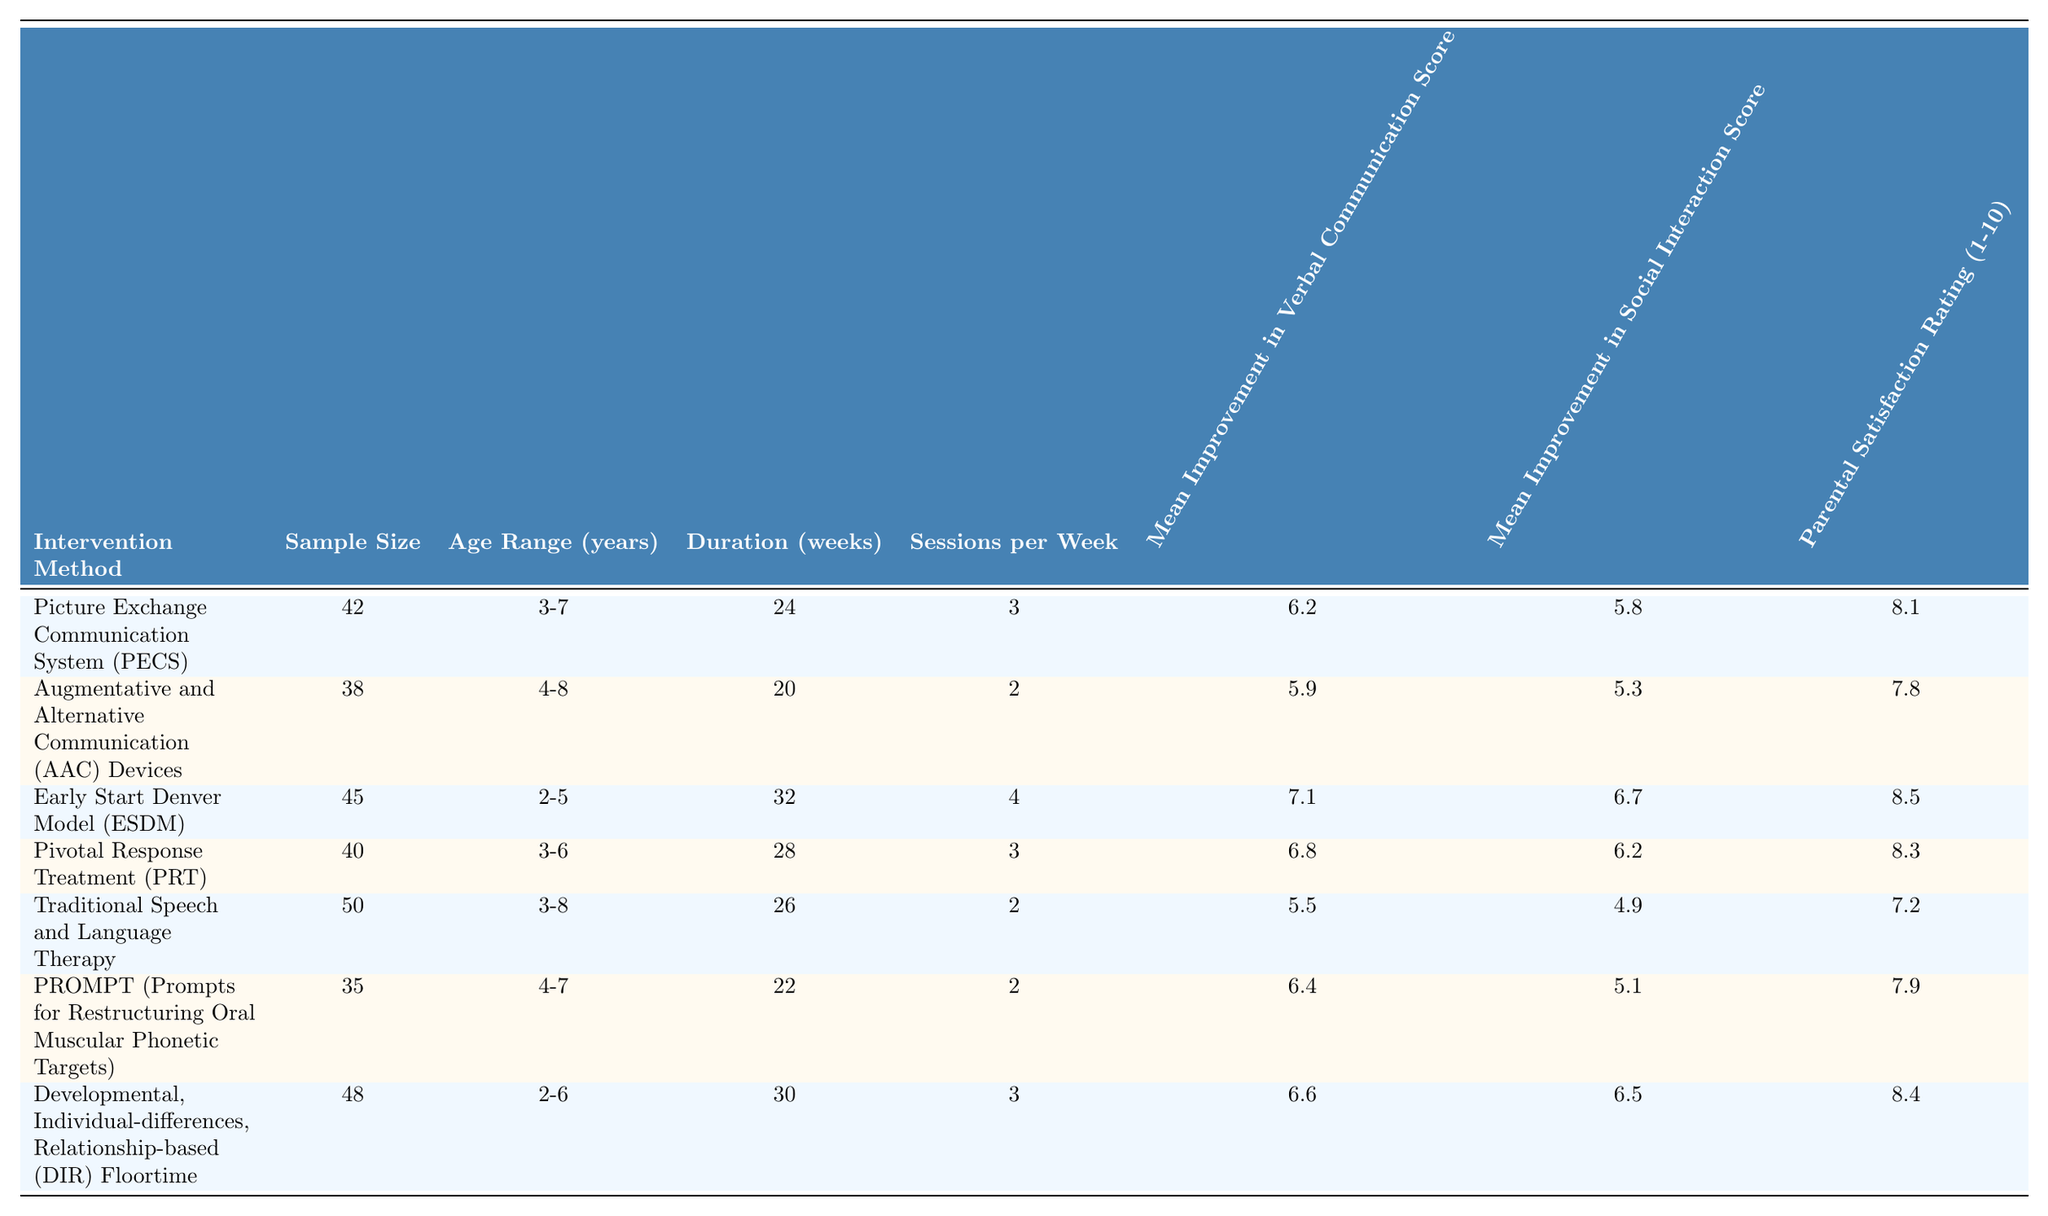What is the mean improvement in verbal communication score for the Early Start Denver Model (ESDM)? The table shows that the mean improvement in verbal communication score for ESDM is 7.1.
Answer: 7.1 What is the sample size of children who received Traditional Speech and Language Therapy? According to the table, the sample size for Traditional Speech and Language Therapy is 50.
Answer: 50 Which intervention method had the highest parental satisfaction rating? The table indicates that the Early Start Denver Model (ESDM) had the highest parental satisfaction rating of 8.5.
Answer: Early Start Denver Model (ESDM) What is the difference in mean improvement in social interaction scores between Picture Exchange Communication System (PECS) and Augmentative and Alternative Communication (AAC) Devices? The mean improvement in social interaction score for PECS is 5.8 and for AAC Devices is 5.3. The difference is 5.8 - 5.3 = 0.5.
Answer: 0.5 Which intervention method had the lowest mean improvement in verbal communication score? From the table, Traditional Speech and Language Therapy has the lowest mean improvement in verbal communication score of 5.5.
Answer: Traditional Speech and Language Therapy How many total weeks of therapy did children receive on average across all intervention methods? To find the average, sum the duration for all methods: 24 + 20 + 32 + 28 + 26 + 22 + 30 = 182. Then divide by the number of methods (7), so 182 / 7 = 26. High (6) and medium (5) scores affect the result.
Answer: 26 Is the mean improvement in verbal communication score higher for DIR Floortime compared to AAC Devices? The mean improvement for DIR Floortime is 6.6, which is higher than 5.9 for AAC Devices. Hence, this statement is true.
Answer: Yes Compare the average age range of children receiving ESDM and PRT interventions. ESDM serves children aged 2-5 years, while PRT serves those aged 3-6 years. ESDM's age range is younger on average.
Answer: ESDM's age range is younger Which intervention had the longest duration of treatment? The table shows that Early Start Denver Model (ESDM) had the longest duration of 32 weeks.
Answer: Early Start Denver Model (ESDM) Calculate the average parental satisfaction rating across all methods. Adding the parental satisfaction ratings yields 8.1 + 7.8 + 8.5 + 8.3 + 7.2 + 7.9 + 8.4 = 56.2. Dividing this by 7 gives an average of approximately 8.0.
Answer: 8.0 